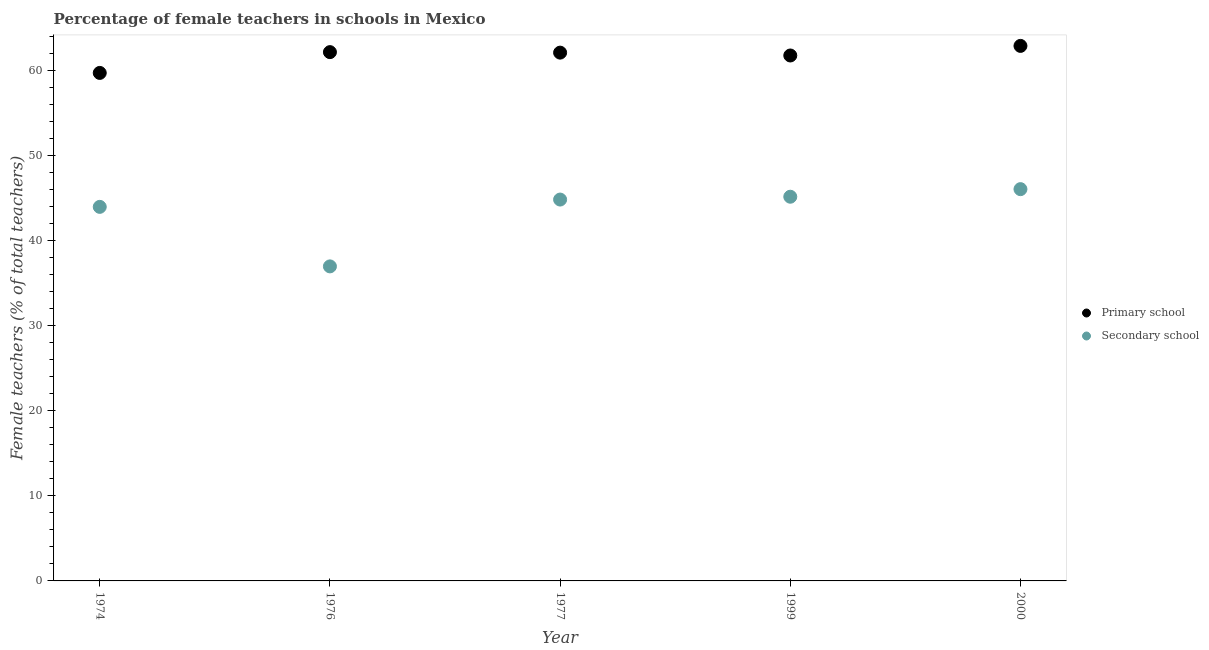How many different coloured dotlines are there?
Provide a short and direct response. 2. Is the number of dotlines equal to the number of legend labels?
Give a very brief answer. Yes. What is the percentage of female teachers in primary schools in 2000?
Offer a terse response. 62.88. Across all years, what is the maximum percentage of female teachers in primary schools?
Provide a short and direct response. 62.88. Across all years, what is the minimum percentage of female teachers in primary schools?
Provide a succinct answer. 59.7. In which year was the percentage of female teachers in primary schools maximum?
Offer a very short reply. 2000. In which year was the percentage of female teachers in secondary schools minimum?
Your answer should be very brief. 1976. What is the total percentage of female teachers in secondary schools in the graph?
Make the answer very short. 216.94. What is the difference between the percentage of female teachers in primary schools in 1976 and that in 1977?
Your answer should be very brief. 0.06. What is the difference between the percentage of female teachers in secondary schools in 1974 and the percentage of female teachers in primary schools in 2000?
Ensure brevity in your answer.  -18.92. What is the average percentage of female teachers in secondary schools per year?
Offer a very short reply. 43.39. In the year 1976, what is the difference between the percentage of female teachers in secondary schools and percentage of female teachers in primary schools?
Give a very brief answer. -25.18. What is the ratio of the percentage of female teachers in secondary schools in 1976 to that in 1977?
Offer a very short reply. 0.82. Is the percentage of female teachers in secondary schools in 1977 less than that in 2000?
Your response must be concise. Yes. What is the difference between the highest and the second highest percentage of female teachers in primary schools?
Your answer should be compact. 0.73. What is the difference between the highest and the lowest percentage of female teachers in primary schools?
Provide a short and direct response. 3.18. In how many years, is the percentage of female teachers in secondary schools greater than the average percentage of female teachers in secondary schools taken over all years?
Your answer should be compact. 4. Does the percentage of female teachers in primary schools monotonically increase over the years?
Provide a succinct answer. No. Does the graph contain any zero values?
Provide a short and direct response. No. Does the graph contain grids?
Give a very brief answer. No. How many legend labels are there?
Offer a very short reply. 2. How are the legend labels stacked?
Offer a terse response. Vertical. What is the title of the graph?
Keep it short and to the point. Percentage of female teachers in schools in Mexico. What is the label or title of the Y-axis?
Give a very brief answer. Female teachers (% of total teachers). What is the Female teachers (% of total teachers) of Primary school in 1974?
Offer a terse response. 59.7. What is the Female teachers (% of total teachers) of Secondary school in 1974?
Offer a terse response. 43.96. What is the Female teachers (% of total teachers) of Primary school in 1976?
Give a very brief answer. 62.15. What is the Female teachers (% of total teachers) in Secondary school in 1976?
Give a very brief answer. 36.97. What is the Female teachers (% of total teachers) of Primary school in 1977?
Make the answer very short. 62.09. What is the Female teachers (% of total teachers) of Secondary school in 1977?
Give a very brief answer. 44.82. What is the Female teachers (% of total teachers) of Primary school in 1999?
Offer a very short reply. 61.75. What is the Female teachers (% of total teachers) of Secondary school in 1999?
Make the answer very short. 45.15. What is the Female teachers (% of total teachers) of Primary school in 2000?
Your response must be concise. 62.88. What is the Female teachers (% of total teachers) of Secondary school in 2000?
Your answer should be very brief. 46.04. Across all years, what is the maximum Female teachers (% of total teachers) of Primary school?
Provide a short and direct response. 62.88. Across all years, what is the maximum Female teachers (% of total teachers) of Secondary school?
Your answer should be compact. 46.04. Across all years, what is the minimum Female teachers (% of total teachers) in Primary school?
Make the answer very short. 59.7. Across all years, what is the minimum Female teachers (% of total teachers) of Secondary school?
Offer a terse response. 36.97. What is the total Female teachers (% of total teachers) of Primary school in the graph?
Your response must be concise. 308.56. What is the total Female teachers (% of total teachers) in Secondary school in the graph?
Provide a short and direct response. 216.94. What is the difference between the Female teachers (% of total teachers) in Primary school in 1974 and that in 1976?
Your answer should be very brief. -2.44. What is the difference between the Female teachers (% of total teachers) in Secondary school in 1974 and that in 1976?
Your response must be concise. 7. What is the difference between the Female teachers (% of total teachers) of Primary school in 1974 and that in 1977?
Your answer should be compact. -2.38. What is the difference between the Female teachers (% of total teachers) in Secondary school in 1974 and that in 1977?
Your answer should be very brief. -0.86. What is the difference between the Female teachers (% of total teachers) of Primary school in 1974 and that in 1999?
Make the answer very short. -2.05. What is the difference between the Female teachers (% of total teachers) of Secondary school in 1974 and that in 1999?
Provide a short and direct response. -1.19. What is the difference between the Female teachers (% of total teachers) in Primary school in 1974 and that in 2000?
Offer a very short reply. -3.18. What is the difference between the Female teachers (% of total teachers) in Secondary school in 1974 and that in 2000?
Provide a succinct answer. -2.08. What is the difference between the Female teachers (% of total teachers) in Primary school in 1976 and that in 1977?
Provide a short and direct response. 0.06. What is the difference between the Female teachers (% of total teachers) of Secondary school in 1976 and that in 1977?
Offer a very short reply. -7.85. What is the difference between the Female teachers (% of total teachers) of Primary school in 1976 and that in 1999?
Give a very brief answer. 0.39. What is the difference between the Female teachers (% of total teachers) of Secondary school in 1976 and that in 1999?
Make the answer very short. -8.19. What is the difference between the Female teachers (% of total teachers) of Primary school in 1976 and that in 2000?
Provide a short and direct response. -0.73. What is the difference between the Female teachers (% of total teachers) in Secondary school in 1976 and that in 2000?
Make the answer very short. -9.08. What is the difference between the Female teachers (% of total teachers) of Primary school in 1977 and that in 1999?
Ensure brevity in your answer.  0.34. What is the difference between the Female teachers (% of total teachers) of Secondary school in 1977 and that in 1999?
Ensure brevity in your answer.  -0.33. What is the difference between the Female teachers (% of total teachers) in Primary school in 1977 and that in 2000?
Your response must be concise. -0.79. What is the difference between the Female teachers (% of total teachers) in Secondary school in 1977 and that in 2000?
Your answer should be very brief. -1.22. What is the difference between the Female teachers (% of total teachers) of Primary school in 1999 and that in 2000?
Your response must be concise. -1.13. What is the difference between the Female teachers (% of total teachers) of Secondary school in 1999 and that in 2000?
Offer a very short reply. -0.89. What is the difference between the Female teachers (% of total teachers) in Primary school in 1974 and the Female teachers (% of total teachers) in Secondary school in 1976?
Give a very brief answer. 22.74. What is the difference between the Female teachers (% of total teachers) of Primary school in 1974 and the Female teachers (% of total teachers) of Secondary school in 1977?
Keep it short and to the point. 14.88. What is the difference between the Female teachers (% of total teachers) in Primary school in 1974 and the Female teachers (% of total teachers) in Secondary school in 1999?
Ensure brevity in your answer.  14.55. What is the difference between the Female teachers (% of total teachers) in Primary school in 1974 and the Female teachers (% of total teachers) in Secondary school in 2000?
Offer a very short reply. 13.66. What is the difference between the Female teachers (% of total teachers) in Primary school in 1976 and the Female teachers (% of total teachers) in Secondary school in 1977?
Provide a succinct answer. 17.33. What is the difference between the Female teachers (% of total teachers) in Primary school in 1976 and the Female teachers (% of total teachers) in Secondary school in 1999?
Offer a terse response. 16.99. What is the difference between the Female teachers (% of total teachers) of Primary school in 1976 and the Female teachers (% of total teachers) of Secondary school in 2000?
Give a very brief answer. 16.1. What is the difference between the Female teachers (% of total teachers) of Primary school in 1977 and the Female teachers (% of total teachers) of Secondary school in 1999?
Keep it short and to the point. 16.94. What is the difference between the Female teachers (% of total teachers) of Primary school in 1977 and the Female teachers (% of total teachers) of Secondary school in 2000?
Offer a very short reply. 16.04. What is the difference between the Female teachers (% of total teachers) in Primary school in 1999 and the Female teachers (% of total teachers) in Secondary school in 2000?
Make the answer very short. 15.71. What is the average Female teachers (% of total teachers) in Primary school per year?
Your response must be concise. 61.71. What is the average Female teachers (% of total teachers) in Secondary school per year?
Your answer should be very brief. 43.39. In the year 1974, what is the difference between the Female teachers (% of total teachers) in Primary school and Female teachers (% of total teachers) in Secondary school?
Give a very brief answer. 15.74. In the year 1976, what is the difference between the Female teachers (% of total teachers) in Primary school and Female teachers (% of total teachers) in Secondary school?
Your answer should be compact. 25.18. In the year 1977, what is the difference between the Female teachers (% of total teachers) of Primary school and Female teachers (% of total teachers) of Secondary school?
Keep it short and to the point. 17.27. In the year 1999, what is the difference between the Female teachers (% of total teachers) of Primary school and Female teachers (% of total teachers) of Secondary school?
Provide a succinct answer. 16.6. In the year 2000, what is the difference between the Female teachers (% of total teachers) of Primary school and Female teachers (% of total teachers) of Secondary school?
Offer a terse response. 16.83. What is the ratio of the Female teachers (% of total teachers) in Primary school in 1974 to that in 1976?
Your response must be concise. 0.96. What is the ratio of the Female teachers (% of total teachers) in Secondary school in 1974 to that in 1976?
Keep it short and to the point. 1.19. What is the ratio of the Female teachers (% of total teachers) of Primary school in 1974 to that in 1977?
Provide a succinct answer. 0.96. What is the ratio of the Female teachers (% of total teachers) in Secondary school in 1974 to that in 1977?
Offer a very short reply. 0.98. What is the ratio of the Female teachers (% of total teachers) of Primary school in 1974 to that in 1999?
Provide a short and direct response. 0.97. What is the ratio of the Female teachers (% of total teachers) of Secondary school in 1974 to that in 1999?
Keep it short and to the point. 0.97. What is the ratio of the Female teachers (% of total teachers) of Primary school in 1974 to that in 2000?
Offer a terse response. 0.95. What is the ratio of the Female teachers (% of total teachers) in Secondary school in 1974 to that in 2000?
Your answer should be compact. 0.95. What is the ratio of the Female teachers (% of total teachers) in Secondary school in 1976 to that in 1977?
Make the answer very short. 0.82. What is the ratio of the Female teachers (% of total teachers) in Primary school in 1976 to that in 1999?
Your answer should be very brief. 1.01. What is the ratio of the Female teachers (% of total teachers) of Secondary school in 1976 to that in 1999?
Your answer should be very brief. 0.82. What is the ratio of the Female teachers (% of total teachers) in Primary school in 1976 to that in 2000?
Your answer should be very brief. 0.99. What is the ratio of the Female teachers (% of total teachers) of Secondary school in 1976 to that in 2000?
Your response must be concise. 0.8. What is the ratio of the Female teachers (% of total teachers) in Primary school in 1977 to that in 1999?
Your response must be concise. 1.01. What is the ratio of the Female teachers (% of total teachers) in Secondary school in 1977 to that in 1999?
Your answer should be very brief. 0.99. What is the ratio of the Female teachers (% of total teachers) in Primary school in 1977 to that in 2000?
Offer a terse response. 0.99. What is the ratio of the Female teachers (% of total teachers) in Secondary school in 1977 to that in 2000?
Provide a short and direct response. 0.97. What is the ratio of the Female teachers (% of total teachers) of Primary school in 1999 to that in 2000?
Provide a succinct answer. 0.98. What is the ratio of the Female teachers (% of total teachers) in Secondary school in 1999 to that in 2000?
Your answer should be compact. 0.98. What is the difference between the highest and the second highest Female teachers (% of total teachers) in Primary school?
Give a very brief answer. 0.73. What is the difference between the highest and the second highest Female teachers (% of total teachers) of Secondary school?
Your answer should be very brief. 0.89. What is the difference between the highest and the lowest Female teachers (% of total teachers) of Primary school?
Provide a short and direct response. 3.18. What is the difference between the highest and the lowest Female teachers (% of total teachers) in Secondary school?
Provide a short and direct response. 9.08. 